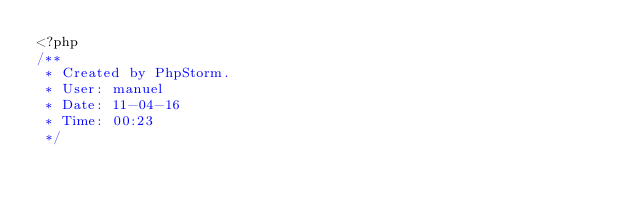<code> <loc_0><loc_0><loc_500><loc_500><_PHP_><?php
/**
 * Created by PhpStorm.
 * User: manuel
 * Date: 11-04-16
 * Time: 00:23
 */</code> 